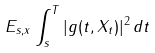<formula> <loc_0><loc_0><loc_500><loc_500>E _ { s , x } \int ^ { T } _ { s } | g ( t , X _ { t } ) | ^ { 2 } \, d t</formula> 